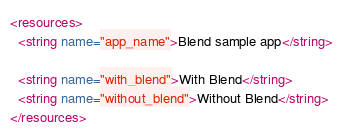<code> <loc_0><loc_0><loc_500><loc_500><_XML_><resources>
  <string name="app_name">Blend sample app</string>

  <string name="with_blend">With Blend</string>
  <string name="without_blend">Without Blend</string>
</resources>
</code> 